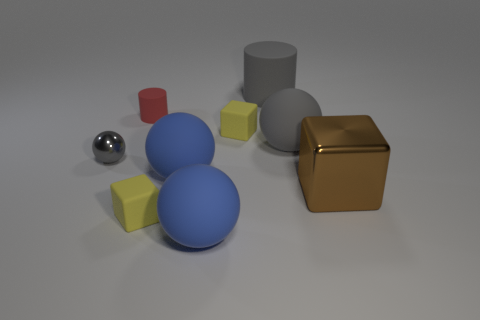What is the large gray object left of the big gray ball made of?
Ensure brevity in your answer.  Rubber. There is another gray thing that is the same shape as the small gray metallic object; what is its material?
Keep it short and to the point. Rubber. Is there a tiny matte cube in front of the large brown shiny thing that is right of the small metal sphere?
Give a very brief answer. Yes. Is the red thing the same shape as the large brown object?
Your answer should be very brief. No. What is the shape of the tiny gray object that is made of the same material as the brown block?
Your answer should be very brief. Sphere. Do the thing that is on the left side of the red rubber cylinder and the shiny object to the right of the gray metal object have the same size?
Keep it short and to the point. No. Are there more tiny red things on the right side of the tiny red matte cylinder than large blue matte things that are behind the gray matte cylinder?
Offer a terse response. No. How many other objects are there of the same color as the big block?
Your answer should be very brief. 0. Do the tiny cylinder and the small block in front of the large shiny object have the same color?
Provide a succinct answer. No. There is a big metallic thing right of the small red matte object; how many gray cylinders are on the right side of it?
Your answer should be compact. 0. 